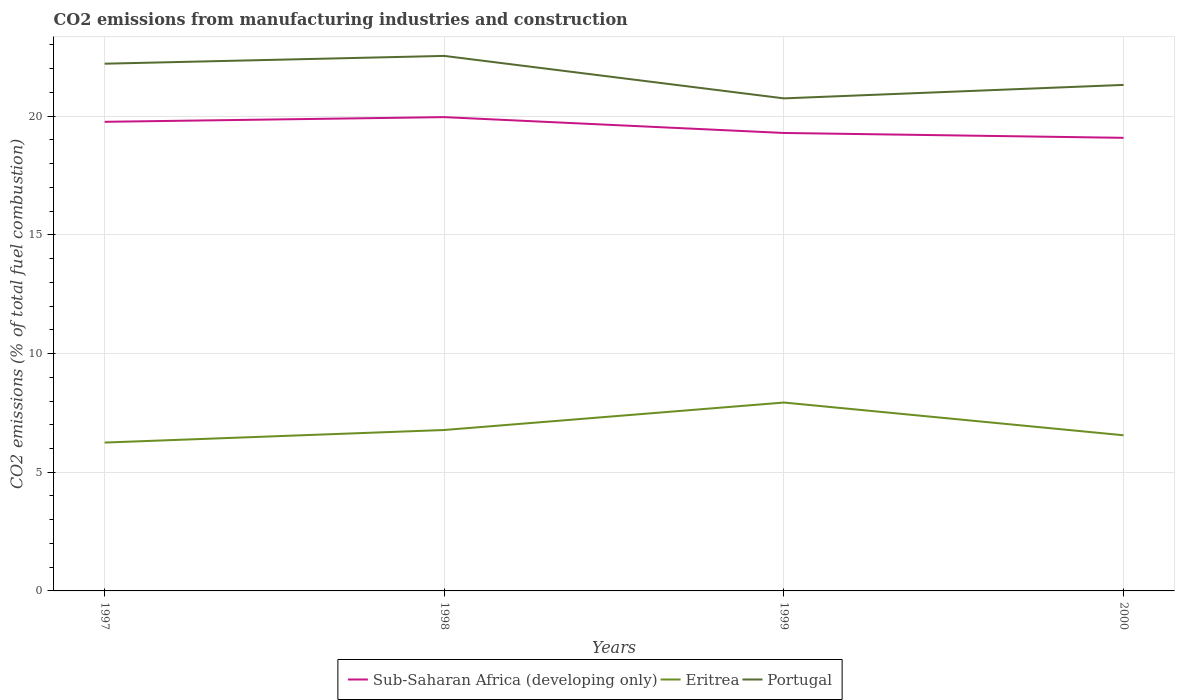How many different coloured lines are there?
Give a very brief answer. 3. Does the line corresponding to Sub-Saharan Africa (developing only) intersect with the line corresponding to Eritrea?
Keep it short and to the point. No. Is the number of lines equal to the number of legend labels?
Your answer should be very brief. Yes. Across all years, what is the maximum amount of CO2 emitted in Sub-Saharan Africa (developing only)?
Provide a short and direct response. 19.09. What is the total amount of CO2 emitted in Eritrea in the graph?
Ensure brevity in your answer.  -1.16. What is the difference between the highest and the second highest amount of CO2 emitted in Portugal?
Give a very brief answer. 1.79. Is the amount of CO2 emitted in Sub-Saharan Africa (developing only) strictly greater than the amount of CO2 emitted in Eritrea over the years?
Offer a terse response. No. Does the graph contain any zero values?
Your answer should be compact. No. How many legend labels are there?
Give a very brief answer. 3. How are the legend labels stacked?
Ensure brevity in your answer.  Horizontal. What is the title of the graph?
Make the answer very short. CO2 emissions from manufacturing industries and construction. Does "Cambodia" appear as one of the legend labels in the graph?
Keep it short and to the point. No. What is the label or title of the Y-axis?
Keep it short and to the point. CO2 emissions (% of total fuel combustion). What is the CO2 emissions (% of total fuel combustion) in Sub-Saharan Africa (developing only) in 1997?
Your answer should be compact. 19.76. What is the CO2 emissions (% of total fuel combustion) in Eritrea in 1997?
Give a very brief answer. 6.25. What is the CO2 emissions (% of total fuel combustion) in Portugal in 1997?
Make the answer very short. 22.21. What is the CO2 emissions (% of total fuel combustion) of Sub-Saharan Africa (developing only) in 1998?
Ensure brevity in your answer.  19.96. What is the CO2 emissions (% of total fuel combustion) in Eritrea in 1998?
Offer a terse response. 6.78. What is the CO2 emissions (% of total fuel combustion) of Portugal in 1998?
Provide a succinct answer. 22.54. What is the CO2 emissions (% of total fuel combustion) of Sub-Saharan Africa (developing only) in 1999?
Keep it short and to the point. 19.29. What is the CO2 emissions (% of total fuel combustion) of Eritrea in 1999?
Offer a very short reply. 7.94. What is the CO2 emissions (% of total fuel combustion) in Portugal in 1999?
Keep it short and to the point. 20.75. What is the CO2 emissions (% of total fuel combustion) of Sub-Saharan Africa (developing only) in 2000?
Keep it short and to the point. 19.09. What is the CO2 emissions (% of total fuel combustion) of Eritrea in 2000?
Offer a terse response. 6.56. What is the CO2 emissions (% of total fuel combustion) of Portugal in 2000?
Provide a succinct answer. 21.32. Across all years, what is the maximum CO2 emissions (% of total fuel combustion) of Sub-Saharan Africa (developing only)?
Keep it short and to the point. 19.96. Across all years, what is the maximum CO2 emissions (% of total fuel combustion) in Eritrea?
Provide a succinct answer. 7.94. Across all years, what is the maximum CO2 emissions (% of total fuel combustion) in Portugal?
Make the answer very short. 22.54. Across all years, what is the minimum CO2 emissions (% of total fuel combustion) of Sub-Saharan Africa (developing only)?
Your response must be concise. 19.09. Across all years, what is the minimum CO2 emissions (% of total fuel combustion) of Eritrea?
Keep it short and to the point. 6.25. Across all years, what is the minimum CO2 emissions (% of total fuel combustion) of Portugal?
Offer a very short reply. 20.75. What is the total CO2 emissions (% of total fuel combustion) in Sub-Saharan Africa (developing only) in the graph?
Give a very brief answer. 78.1. What is the total CO2 emissions (% of total fuel combustion) in Eritrea in the graph?
Your answer should be very brief. 27.52. What is the total CO2 emissions (% of total fuel combustion) of Portugal in the graph?
Provide a succinct answer. 86.82. What is the difference between the CO2 emissions (% of total fuel combustion) in Sub-Saharan Africa (developing only) in 1997 and that in 1998?
Your answer should be compact. -0.2. What is the difference between the CO2 emissions (% of total fuel combustion) of Eritrea in 1997 and that in 1998?
Give a very brief answer. -0.53. What is the difference between the CO2 emissions (% of total fuel combustion) of Portugal in 1997 and that in 1998?
Provide a short and direct response. -0.33. What is the difference between the CO2 emissions (% of total fuel combustion) in Sub-Saharan Africa (developing only) in 1997 and that in 1999?
Make the answer very short. 0.47. What is the difference between the CO2 emissions (% of total fuel combustion) of Eritrea in 1997 and that in 1999?
Ensure brevity in your answer.  -1.69. What is the difference between the CO2 emissions (% of total fuel combustion) of Portugal in 1997 and that in 1999?
Offer a very short reply. 1.46. What is the difference between the CO2 emissions (% of total fuel combustion) of Sub-Saharan Africa (developing only) in 1997 and that in 2000?
Provide a succinct answer. 0.67. What is the difference between the CO2 emissions (% of total fuel combustion) in Eritrea in 1997 and that in 2000?
Your response must be concise. -0.31. What is the difference between the CO2 emissions (% of total fuel combustion) of Portugal in 1997 and that in 2000?
Keep it short and to the point. 0.89. What is the difference between the CO2 emissions (% of total fuel combustion) of Sub-Saharan Africa (developing only) in 1998 and that in 1999?
Your answer should be compact. 0.67. What is the difference between the CO2 emissions (% of total fuel combustion) in Eritrea in 1998 and that in 1999?
Your answer should be very brief. -1.16. What is the difference between the CO2 emissions (% of total fuel combustion) in Portugal in 1998 and that in 1999?
Keep it short and to the point. 1.79. What is the difference between the CO2 emissions (% of total fuel combustion) in Sub-Saharan Africa (developing only) in 1998 and that in 2000?
Keep it short and to the point. 0.87. What is the difference between the CO2 emissions (% of total fuel combustion) of Eritrea in 1998 and that in 2000?
Offer a very short reply. 0.22. What is the difference between the CO2 emissions (% of total fuel combustion) of Portugal in 1998 and that in 2000?
Give a very brief answer. 1.22. What is the difference between the CO2 emissions (% of total fuel combustion) in Sub-Saharan Africa (developing only) in 1999 and that in 2000?
Offer a terse response. 0.21. What is the difference between the CO2 emissions (% of total fuel combustion) of Eritrea in 1999 and that in 2000?
Your answer should be compact. 1.38. What is the difference between the CO2 emissions (% of total fuel combustion) in Portugal in 1999 and that in 2000?
Ensure brevity in your answer.  -0.57. What is the difference between the CO2 emissions (% of total fuel combustion) in Sub-Saharan Africa (developing only) in 1997 and the CO2 emissions (% of total fuel combustion) in Eritrea in 1998?
Your response must be concise. 12.98. What is the difference between the CO2 emissions (% of total fuel combustion) of Sub-Saharan Africa (developing only) in 1997 and the CO2 emissions (% of total fuel combustion) of Portugal in 1998?
Provide a succinct answer. -2.78. What is the difference between the CO2 emissions (% of total fuel combustion) of Eritrea in 1997 and the CO2 emissions (% of total fuel combustion) of Portugal in 1998?
Your response must be concise. -16.29. What is the difference between the CO2 emissions (% of total fuel combustion) of Sub-Saharan Africa (developing only) in 1997 and the CO2 emissions (% of total fuel combustion) of Eritrea in 1999?
Offer a very short reply. 11.83. What is the difference between the CO2 emissions (% of total fuel combustion) of Sub-Saharan Africa (developing only) in 1997 and the CO2 emissions (% of total fuel combustion) of Portugal in 1999?
Your answer should be compact. -0.99. What is the difference between the CO2 emissions (% of total fuel combustion) in Eritrea in 1997 and the CO2 emissions (% of total fuel combustion) in Portugal in 1999?
Offer a terse response. -14.5. What is the difference between the CO2 emissions (% of total fuel combustion) in Sub-Saharan Africa (developing only) in 1997 and the CO2 emissions (% of total fuel combustion) in Eritrea in 2000?
Provide a succinct answer. 13.21. What is the difference between the CO2 emissions (% of total fuel combustion) of Sub-Saharan Africa (developing only) in 1997 and the CO2 emissions (% of total fuel combustion) of Portugal in 2000?
Provide a short and direct response. -1.55. What is the difference between the CO2 emissions (% of total fuel combustion) of Eritrea in 1997 and the CO2 emissions (% of total fuel combustion) of Portugal in 2000?
Make the answer very short. -15.07. What is the difference between the CO2 emissions (% of total fuel combustion) of Sub-Saharan Africa (developing only) in 1998 and the CO2 emissions (% of total fuel combustion) of Eritrea in 1999?
Ensure brevity in your answer.  12.02. What is the difference between the CO2 emissions (% of total fuel combustion) of Sub-Saharan Africa (developing only) in 1998 and the CO2 emissions (% of total fuel combustion) of Portugal in 1999?
Provide a succinct answer. -0.79. What is the difference between the CO2 emissions (% of total fuel combustion) in Eritrea in 1998 and the CO2 emissions (% of total fuel combustion) in Portugal in 1999?
Your answer should be very brief. -13.97. What is the difference between the CO2 emissions (% of total fuel combustion) in Sub-Saharan Africa (developing only) in 1998 and the CO2 emissions (% of total fuel combustion) in Eritrea in 2000?
Keep it short and to the point. 13.4. What is the difference between the CO2 emissions (% of total fuel combustion) in Sub-Saharan Africa (developing only) in 1998 and the CO2 emissions (% of total fuel combustion) in Portugal in 2000?
Offer a very short reply. -1.36. What is the difference between the CO2 emissions (% of total fuel combustion) in Eritrea in 1998 and the CO2 emissions (% of total fuel combustion) in Portugal in 2000?
Keep it short and to the point. -14.54. What is the difference between the CO2 emissions (% of total fuel combustion) in Sub-Saharan Africa (developing only) in 1999 and the CO2 emissions (% of total fuel combustion) in Eritrea in 2000?
Provide a succinct answer. 12.74. What is the difference between the CO2 emissions (% of total fuel combustion) of Sub-Saharan Africa (developing only) in 1999 and the CO2 emissions (% of total fuel combustion) of Portugal in 2000?
Offer a very short reply. -2.02. What is the difference between the CO2 emissions (% of total fuel combustion) of Eritrea in 1999 and the CO2 emissions (% of total fuel combustion) of Portugal in 2000?
Ensure brevity in your answer.  -13.38. What is the average CO2 emissions (% of total fuel combustion) of Sub-Saharan Africa (developing only) per year?
Your answer should be very brief. 19.53. What is the average CO2 emissions (% of total fuel combustion) in Eritrea per year?
Offer a terse response. 6.88. What is the average CO2 emissions (% of total fuel combustion) in Portugal per year?
Your answer should be very brief. 21.7. In the year 1997, what is the difference between the CO2 emissions (% of total fuel combustion) in Sub-Saharan Africa (developing only) and CO2 emissions (% of total fuel combustion) in Eritrea?
Your response must be concise. 13.51. In the year 1997, what is the difference between the CO2 emissions (% of total fuel combustion) in Sub-Saharan Africa (developing only) and CO2 emissions (% of total fuel combustion) in Portugal?
Keep it short and to the point. -2.45. In the year 1997, what is the difference between the CO2 emissions (% of total fuel combustion) in Eritrea and CO2 emissions (% of total fuel combustion) in Portugal?
Make the answer very short. -15.96. In the year 1998, what is the difference between the CO2 emissions (% of total fuel combustion) of Sub-Saharan Africa (developing only) and CO2 emissions (% of total fuel combustion) of Eritrea?
Give a very brief answer. 13.18. In the year 1998, what is the difference between the CO2 emissions (% of total fuel combustion) of Sub-Saharan Africa (developing only) and CO2 emissions (% of total fuel combustion) of Portugal?
Offer a very short reply. -2.58. In the year 1998, what is the difference between the CO2 emissions (% of total fuel combustion) in Eritrea and CO2 emissions (% of total fuel combustion) in Portugal?
Give a very brief answer. -15.76. In the year 1999, what is the difference between the CO2 emissions (% of total fuel combustion) of Sub-Saharan Africa (developing only) and CO2 emissions (% of total fuel combustion) of Eritrea?
Keep it short and to the point. 11.36. In the year 1999, what is the difference between the CO2 emissions (% of total fuel combustion) of Sub-Saharan Africa (developing only) and CO2 emissions (% of total fuel combustion) of Portugal?
Provide a short and direct response. -1.46. In the year 1999, what is the difference between the CO2 emissions (% of total fuel combustion) of Eritrea and CO2 emissions (% of total fuel combustion) of Portugal?
Make the answer very short. -12.81. In the year 2000, what is the difference between the CO2 emissions (% of total fuel combustion) in Sub-Saharan Africa (developing only) and CO2 emissions (% of total fuel combustion) in Eritrea?
Ensure brevity in your answer.  12.53. In the year 2000, what is the difference between the CO2 emissions (% of total fuel combustion) of Sub-Saharan Africa (developing only) and CO2 emissions (% of total fuel combustion) of Portugal?
Offer a terse response. -2.23. In the year 2000, what is the difference between the CO2 emissions (% of total fuel combustion) in Eritrea and CO2 emissions (% of total fuel combustion) in Portugal?
Provide a short and direct response. -14.76. What is the ratio of the CO2 emissions (% of total fuel combustion) of Eritrea in 1997 to that in 1998?
Your response must be concise. 0.92. What is the ratio of the CO2 emissions (% of total fuel combustion) of Portugal in 1997 to that in 1998?
Give a very brief answer. 0.99. What is the ratio of the CO2 emissions (% of total fuel combustion) in Sub-Saharan Africa (developing only) in 1997 to that in 1999?
Your response must be concise. 1.02. What is the ratio of the CO2 emissions (% of total fuel combustion) in Eritrea in 1997 to that in 1999?
Your answer should be very brief. 0.79. What is the ratio of the CO2 emissions (% of total fuel combustion) of Portugal in 1997 to that in 1999?
Give a very brief answer. 1.07. What is the ratio of the CO2 emissions (% of total fuel combustion) of Sub-Saharan Africa (developing only) in 1997 to that in 2000?
Offer a terse response. 1.04. What is the ratio of the CO2 emissions (% of total fuel combustion) of Eritrea in 1997 to that in 2000?
Provide a short and direct response. 0.95. What is the ratio of the CO2 emissions (% of total fuel combustion) in Portugal in 1997 to that in 2000?
Offer a very short reply. 1.04. What is the ratio of the CO2 emissions (% of total fuel combustion) of Sub-Saharan Africa (developing only) in 1998 to that in 1999?
Offer a terse response. 1.03. What is the ratio of the CO2 emissions (% of total fuel combustion) in Eritrea in 1998 to that in 1999?
Make the answer very short. 0.85. What is the ratio of the CO2 emissions (% of total fuel combustion) of Portugal in 1998 to that in 1999?
Keep it short and to the point. 1.09. What is the ratio of the CO2 emissions (% of total fuel combustion) of Sub-Saharan Africa (developing only) in 1998 to that in 2000?
Ensure brevity in your answer.  1.05. What is the ratio of the CO2 emissions (% of total fuel combustion) in Eritrea in 1998 to that in 2000?
Offer a terse response. 1.03. What is the ratio of the CO2 emissions (% of total fuel combustion) in Portugal in 1998 to that in 2000?
Offer a terse response. 1.06. What is the ratio of the CO2 emissions (% of total fuel combustion) of Sub-Saharan Africa (developing only) in 1999 to that in 2000?
Offer a very short reply. 1.01. What is the ratio of the CO2 emissions (% of total fuel combustion) in Eritrea in 1999 to that in 2000?
Ensure brevity in your answer.  1.21. What is the ratio of the CO2 emissions (% of total fuel combustion) of Portugal in 1999 to that in 2000?
Give a very brief answer. 0.97. What is the difference between the highest and the second highest CO2 emissions (% of total fuel combustion) in Sub-Saharan Africa (developing only)?
Your response must be concise. 0.2. What is the difference between the highest and the second highest CO2 emissions (% of total fuel combustion) in Eritrea?
Offer a very short reply. 1.16. What is the difference between the highest and the second highest CO2 emissions (% of total fuel combustion) in Portugal?
Your response must be concise. 0.33. What is the difference between the highest and the lowest CO2 emissions (% of total fuel combustion) of Sub-Saharan Africa (developing only)?
Provide a short and direct response. 0.87. What is the difference between the highest and the lowest CO2 emissions (% of total fuel combustion) of Eritrea?
Your answer should be compact. 1.69. What is the difference between the highest and the lowest CO2 emissions (% of total fuel combustion) of Portugal?
Your answer should be compact. 1.79. 